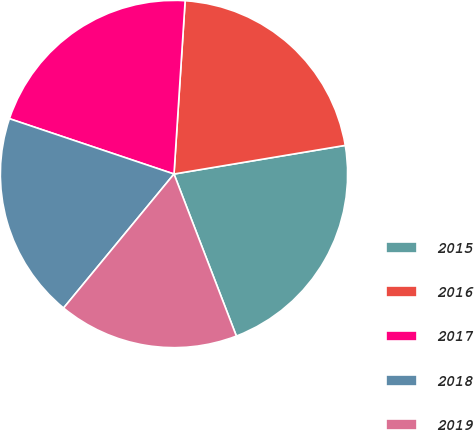Convert chart. <chart><loc_0><loc_0><loc_500><loc_500><pie_chart><fcel>2015<fcel>2016<fcel>2017<fcel>2018<fcel>2019<nl><fcel>21.79%<fcel>21.34%<fcel>20.86%<fcel>19.19%<fcel>16.82%<nl></chart> 